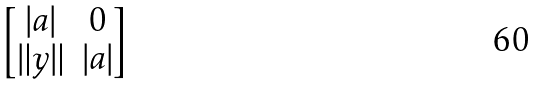Convert formula to latex. <formula><loc_0><loc_0><loc_500><loc_500>\begin{bmatrix} | a | & 0 \\ \| y \| & | a | \end{bmatrix}</formula> 